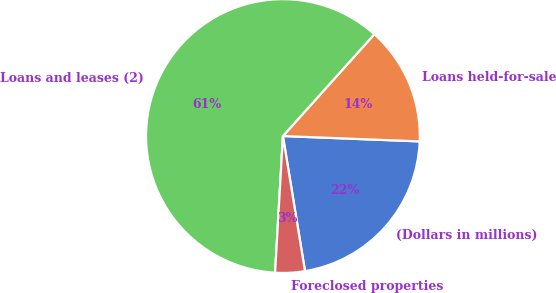Convert chart to OTSL. <chart><loc_0><loc_0><loc_500><loc_500><pie_chart><fcel>(Dollars in millions)<fcel>Loans held-for-sale<fcel>Loans and leases (2)<fcel>Foreclosed properties<nl><fcel>21.8%<fcel>13.98%<fcel>60.73%<fcel>3.49%<nl></chart> 